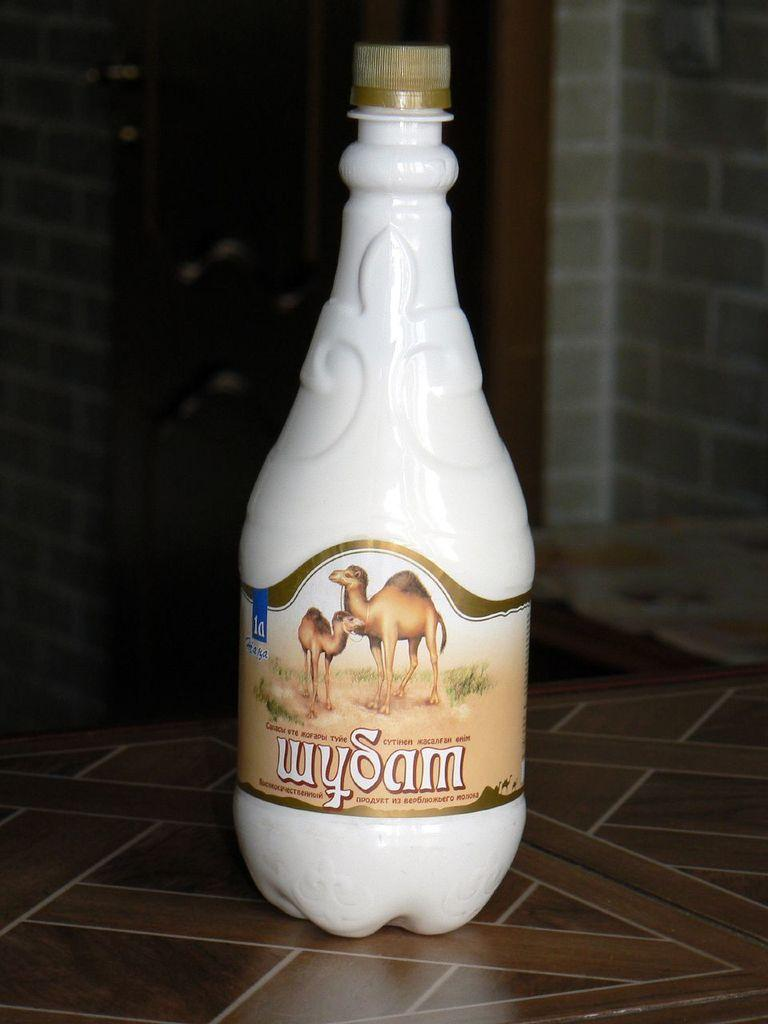Provide a one-sentence caption for the provided image. A bottle of wySam shows two camels on the label. 